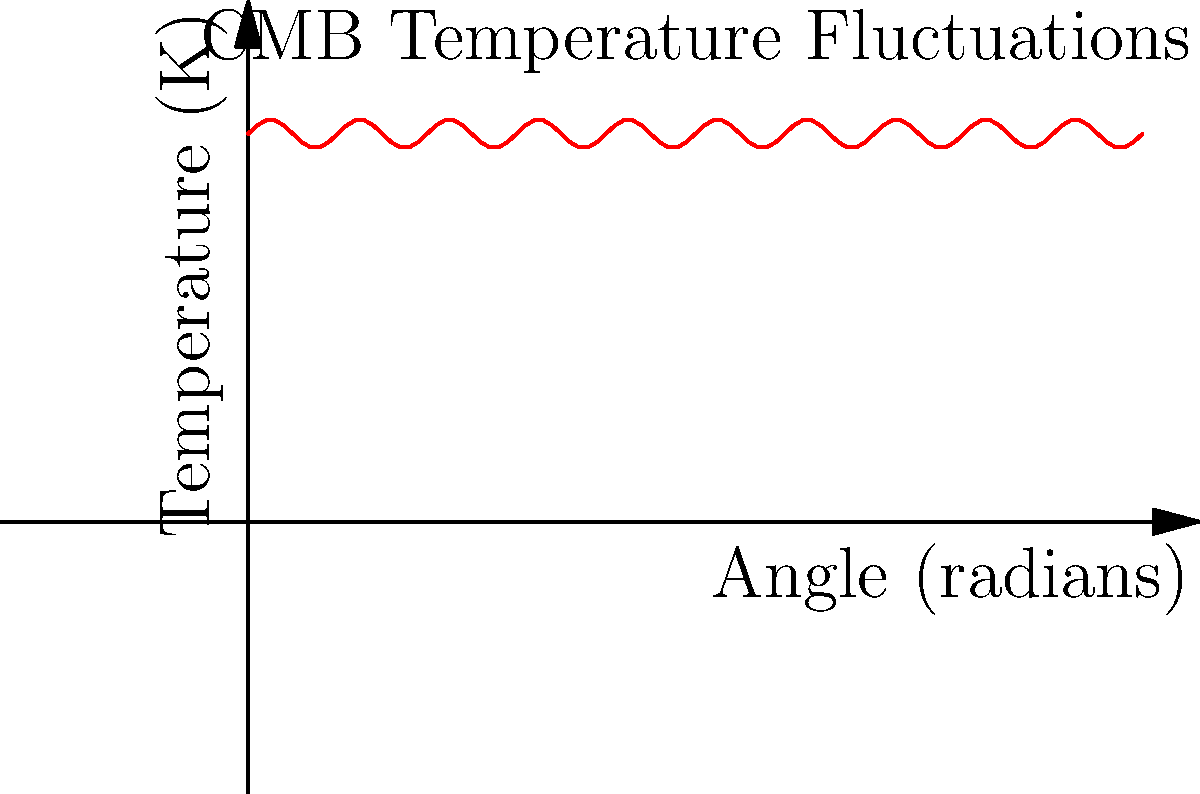In the context of cosmic equality, how do the temperature fluctuations in the Cosmic Microwave Background (CMB) radiation, as shown in the graph, relate to the concept of universal fairness in resource distribution? To answer this question, let's analyze the graph and its implications step-by-step:

1. The graph shows the temperature fluctuations in the CMB radiation across different angles in the sky.

2. The average temperature of the CMB is about 2.725 Kelvin, as seen on the y-axis.

3. The fluctuations around this average are extremely small, on the order of $10^{-5}$ Kelvin, as depicted by the slight variations in the red line.

4. These tiny fluctuations represent the seeds of cosmic structure formation, leading to the galaxies and large-scale structures we see today.

5. From a socialist perspective, we can draw parallels between these fluctuations and resource distribution:
   a) The overall uniformity of the CMB (small fluctuations) suggests a inherent "fairness" in the early universe.
   b) However, these small initial differences led to the current uneven distribution of matter in the universe.

6. This can be seen as an analogy to how small initial inequalities in society can lead to larger disparities over time.

7. The concept of "cosmic equality" is challenged by these fluctuations, much like how small economic differences can grow into larger inequalities in capitalist systems.

8. Just as intervention might be necessary to maintain fairness in resource distribution on Earth, one could argue that the universe required specific conditions (like inflation) to achieve its observed level of uniformity.
Answer: CMB fluctuations represent initial cosmic "inequalities" that led to current large-scale structures, mirroring how small societal disparities can grow into significant inequalities over time. 